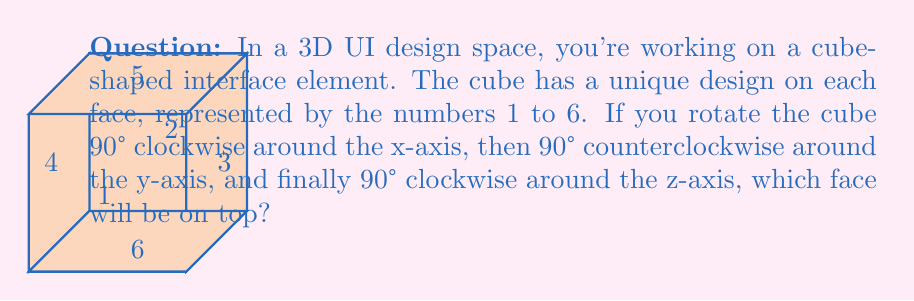Can you solve this math problem? Let's follow the rotations step-by-step:

1) Initial state: Face 1 is on top.

2) 90° clockwise rotation around x-axis:
   - Face 1 moves to the front
   - Face 5 moves to the top
   - Face 2 moves to the back
   - Face 6 moves to the bottom
   - Faces 3 and 4 remain on the sides

3) 90° counterclockwise rotation around y-axis:
   - Face 5 remains on top
   - Face 3 moves to the front
   - Face 4 moves to the back
   - Face 1 moves to the right side
   - Face 2 moves to the left side
   - Face 6 remains on the bottom

4) 90° clockwise rotation around z-axis:
   - Face 1 moves to the top
   - Face 5 moves to the right side
   - Face 2 moves to the bottom
   - Face 6 moves to the left side
   - Face 3 moves to the top (was front)
   - Face 4 remains at the back

Therefore, after all rotations, Face 3 ends up on top.

This sequence of rotations can be represented mathematically using rotation matrices:

$$R_z(90°) \cdot R_y(-90°) \cdot R_x(90°)$$

Where $R_x$, $R_y$, and $R_z$ are rotation matrices around the x, y, and z axes respectively.
Answer: 3 